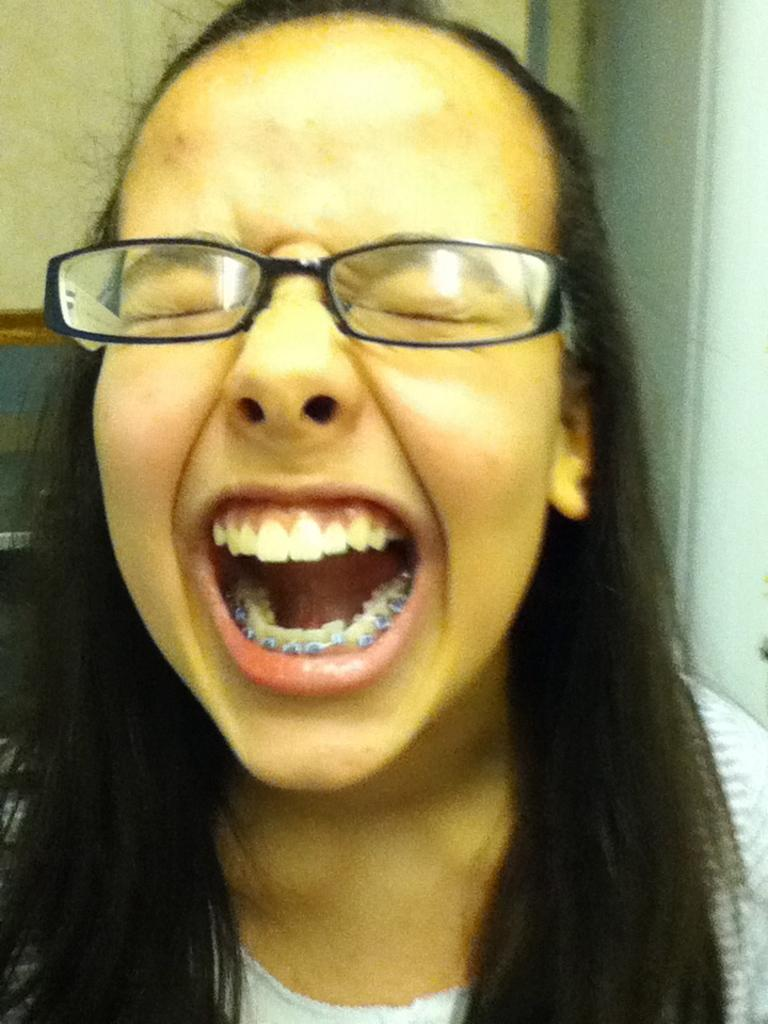What is the main subject of the image? The main subject of the image is a woman. Can you describe the woman's attire? The woman is wearing a dress. What accessory is the woman wearing on her face? The woman is wearing spectacles. What is the woman doing in the image? The woman has closed her eyes. Are there any unusual features on the woman's teeth? Yes, there are clips on the woman's teeth. What can be seen in the background of the image? There is a wall in the background of the image. What type of liquid is being poured into the notebook in the image? There is no notebook or liquid present in the image. What is the woman doing to the earth in the image? There is no earth or action involving the earth depicted in the image. 